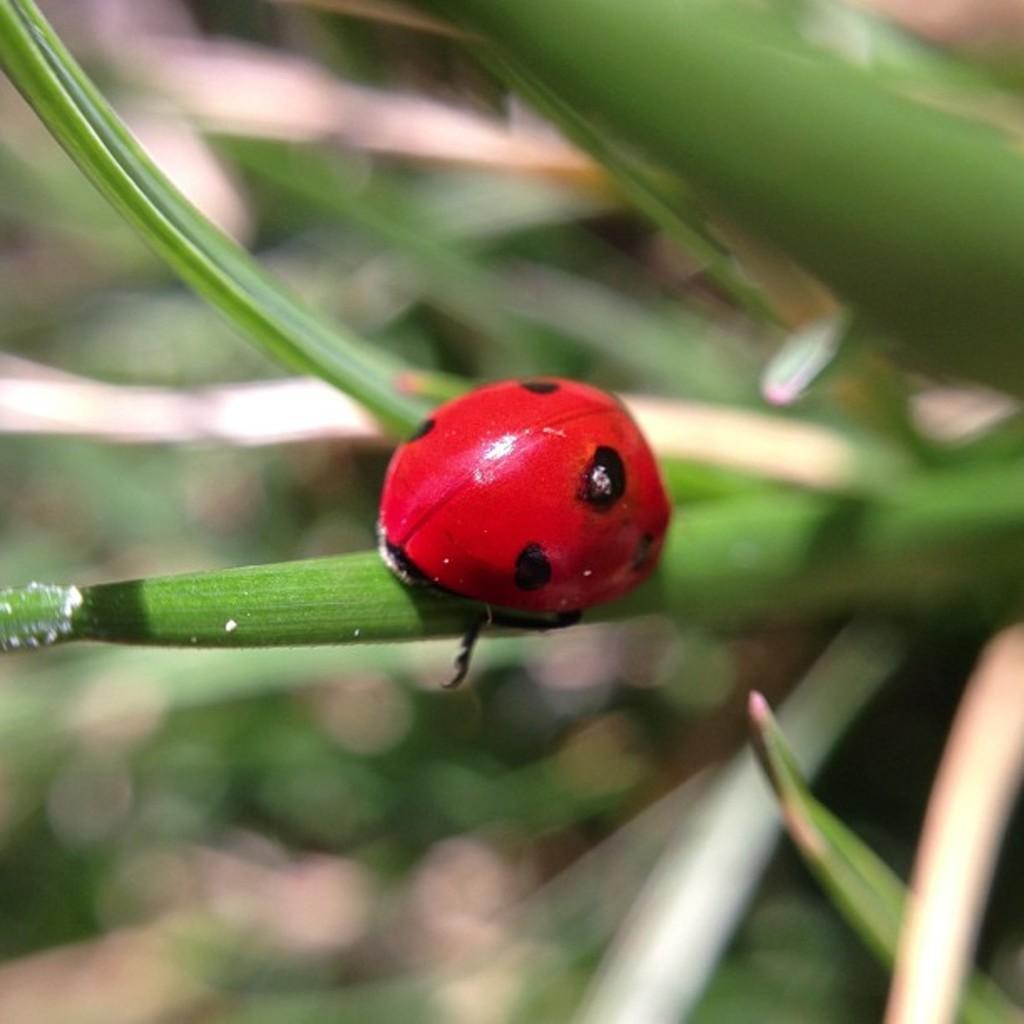In one or two sentences, can you explain what this image depicts? In this image we can see an insect on the leaf and a blurry background. 